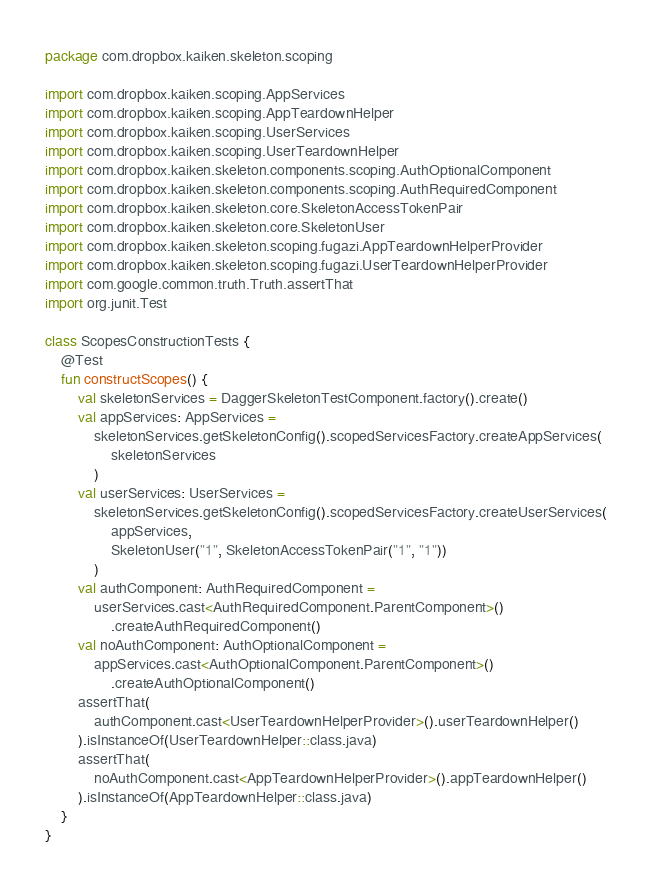<code> <loc_0><loc_0><loc_500><loc_500><_Kotlin_>package com.dropbox.kaiken.skeleton.scoping

import com.dropbox.kaiken.scoping.AppServices
import com.dropbox.kaiken.scoping.AppTeardownHelper
import com.dropbox.kaiken.scoping.UserServices
import com.dropbox.kaiken.scoping.UserTeardownHelper
import com.dropbox.kaiken.skeleton.components.scoping.AuthOptionalComponent
import com.dropbox.kaiken.skeleton.components.scoping.AuthRequiredComponent
import com.dropbox.kaiken.skeleton.core.SkeletonAccessTokenPair
import com.dropbox.kaiken.skeleton.core.SkeletonUser
import com.dropbox.kaiken.skeleton.scoping.fugazi.AppTeardownHelperProvider
import com.dropbox.kaiken.skeleton.scoping.fugazi.UserTeardownHelperProvider
import com.google.common.truth.Truth.assertThat
import org.junit.Test

class ScopesConstructionTests {
    @Test
    fun constructScopes() {
        val skeletonServices = DaggerSkeletonTestComponent.factory().create()
        val appServices: AppServices =
            skeletonServices.getSkeletonConfig().scopedServicesFactory.createAppServices(
                skeletonServices
            )
        val userServices: UserServices =
            skeletonServices.getSkeletonConfig().scopedServicesFactory.createUserServices(
                appServices,
                SkeletonUser("1", SkeletonAccessTokenPair("1", "1"))
            )
        val authComponent: AuthRequiredComponent =
            userServices.cast<AuthRequiredComponent.ParentComponent>()
                .createAuthRequiredComponent()
        val noAuthComponent: AuthOptionalComponent =
            appServices.cast<AuthOptionalComponent.ParentComponent>()
                .createAuthOptionalComponent()
        assertThat(
            authComponent.cast<UserTeardownHelperProvider>().userTeardownHelper()
        ).isInstanceOf(UserTeardownHelper::class.java)
        assertThat(
            noAuthComponent.cast<AppTeardownHelperProvider>().appTeardownHelper()
        ).isInstanceOf(AppTeardownHelper::class.java)
    }
}
</code> 